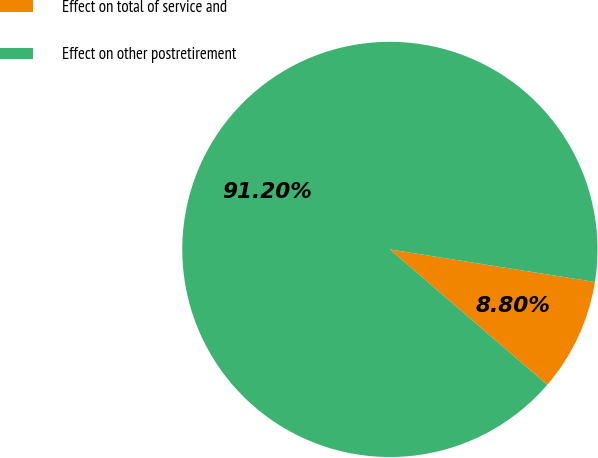<chart> <loc_0><loc_0><loc_500><loc_500><pie_chart><fcel>Effect on total of service and<fcel>Effect on other postretirement<nl><fcel>8.8%<fcel>91.2%<nl></chart> 